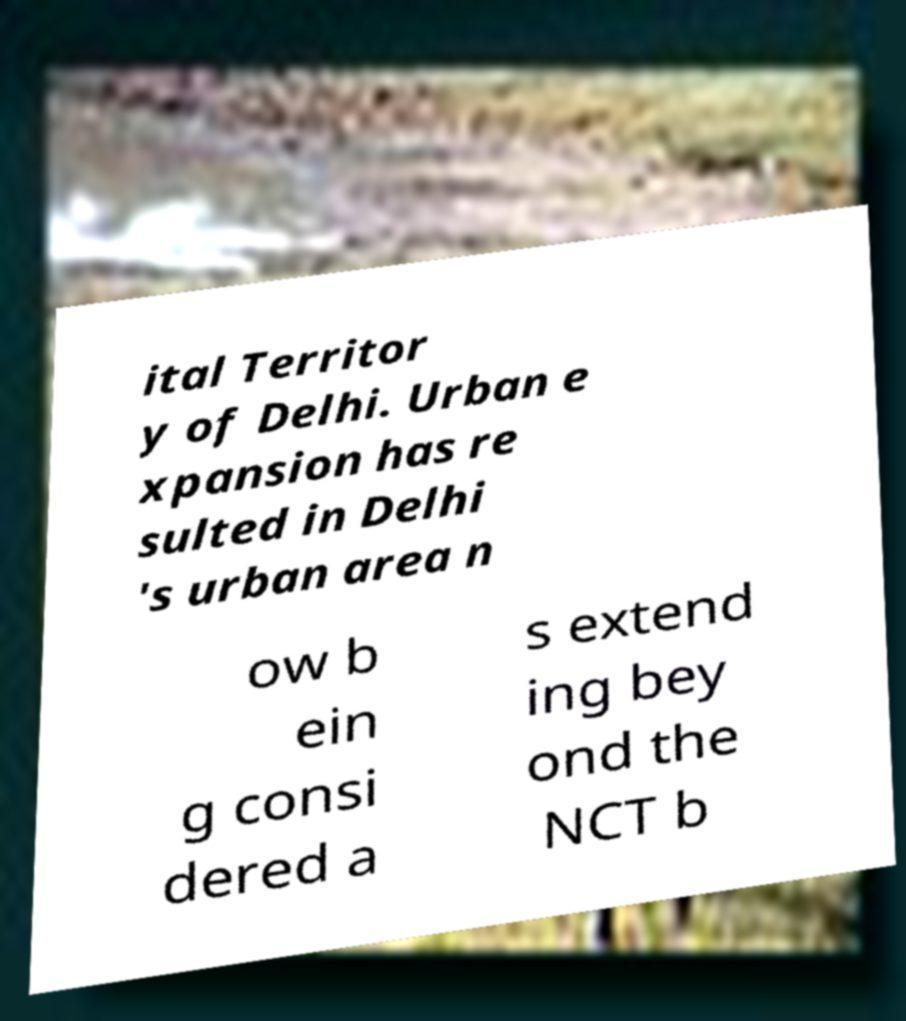Please identify and transcribe the text found in this image. ital Territor y of Delhi. Urban e xpansion has re sulted in Delhi 's urban area n ow b ein g consi dered a s extend ing bey ond the NCT b 